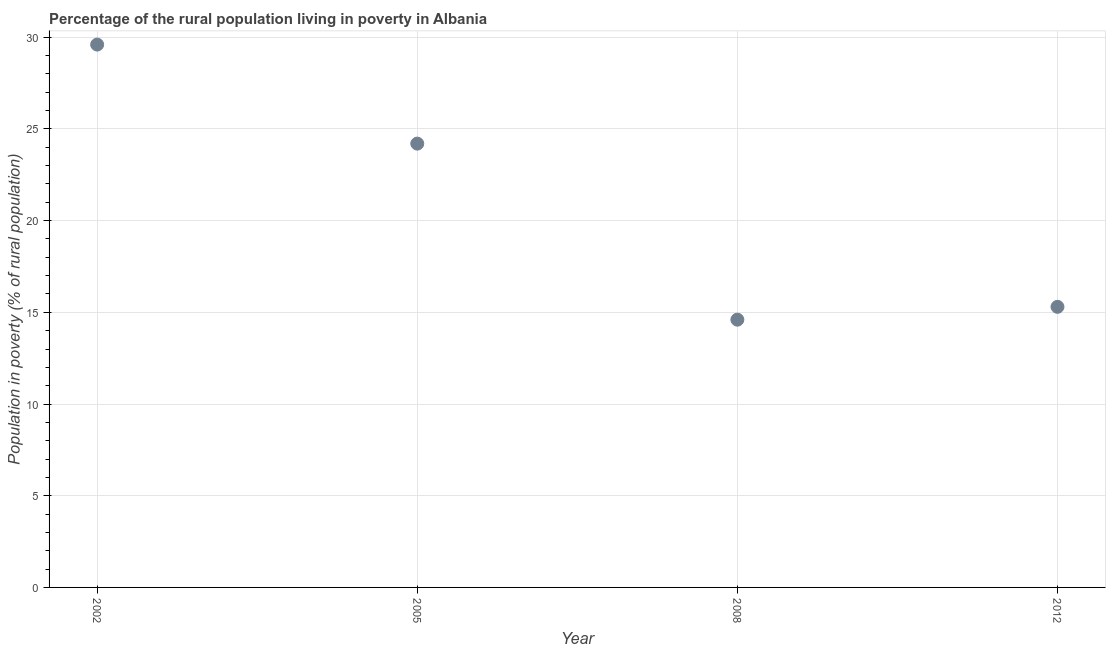What is the percentage of rural population living below poverty line in 2002?
Provide a succinct answer. 29.6. Across all years, what is the maximum percentage of rural population living below poverty line?
Your answer should be very brief. 29.6. Across all years, what is the minimum percentage of rural population living below poverty line?
Keep it short and to the point. 14.6. In which year was the percentage of rural population living below poverty line maximum?
Make the answer very short. 2002. What is the sum of the percentage of rural population living below poverty line?
Offer a very short reply. 83.7. What is the average percentage of rural population living below poverty line per year?
Provide a succinct answer. 20.92. What is the median percentage of rural population living below poverty line?
Offer a terse response. 19.75. Do a majority of the years between 2002 and 2008 (inclusive) have percentage of rural population living below poverty line greater than 19 %?
Your response must be concise. Yes. What is the ratio of the percentage of rural population living below poverty line in 2002 to that in 2005?
Provide a succinct answer. 1.22. Is the percentage of rural population living below poverty line in 2005 less than that in 2012?
Make the answer very short. No. What is the difference between the highest and the second highest percentage of rural population living below poverty line?
Your response must be concise. 5.4. Is the sum of the percentage of rural population living below poverty line in 2002 and 2008 greater than the maximum percentage of rural population living below poverty line across all years?
Offer a very short reply. Yes. What is the difference between the highest and the lowest percentage of rural population living below poverty line?
Keep it short and to the point. 15. In how many years, is the percentage of rural population living below poverty line greater than the average percentage of rural population living below poverty line taken over all years?
Keep it short and to the point. 2. How many dotlines are there?
Ensure brevity in your answer.  1. How many years are there in the graph?
Keep it short and to the point. 4. What is the difference between two consecutive major ticks on the Y-axis?
Provide a succinct answer. 5. What is the title of the graph?
Offer a terse response. Percentage of the rural population living in poverty in Albania. What is the label or title of the Y-axis?
Make the answer very short. Population in poverty (% of rural population). What is the Population in poverty (% of rural population) in 2002?
Provide a succinct answer. 29.6. What is the Population in poverty (% of rural population) in 2005?
Your response must be concise. 24.2. What is the Population in poverty (% of rural population) in 2012?
Keep it short and to the point. 15.3. What is the difference between the Population in poverty (% of rural population) in 2002 and 2005?
Your response must be concise. 5.4. What is the difference between the Population in poverty (% of rural population) in 2005 and 2008?
Make the answer very short. 9.6. What is the ratio of the Population in poverty (% of rural population) in 2002 to that in 2005?
Provide a succinct answer. 1.22. What is the ratio of the Population in poverty (% of rural population) in 2002 to that in 2008?
Make the answer very short. 2.03. What is the ratio of the Population in poverty (% of rural population) in 2002 to that in 2012?
Make the answer very short. 1.94. What is the ratio of the Population in poverty (% of rural population) in 2005 to that in 2008?
Give a very brief answer. 1.66. What is the ratio of the Population in poverty (% of rural population) in 2005 to that in 2012?
Your answer should be very brief. 1.58. What is the ratio of the Population in poverty (% of rural population) in 2008 to that in 2012?
Make the answer very short. 0.95. 